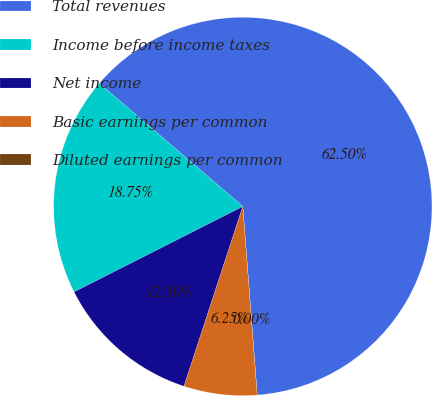Convert chart. <chart><loc_0><loc_0><loc_500><loc_500><pie_chart><fcel>Total revenues<fcel>Income before income taxes<fcel>Net income<fcel>Basic earnings per common<fcel>Diluted earnings per common<nl><fcel>62.5%<fcel>18.75%<fcel>12.5%<fcel>6.25%<fcel>0.0%<nl></chart> 